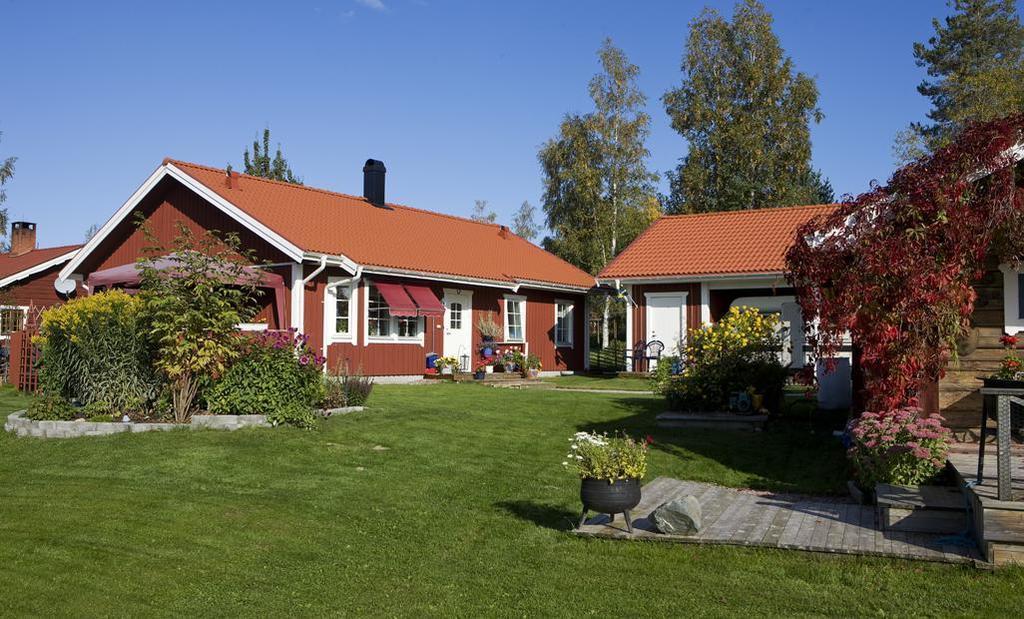Please provide a concise description of this image. These are the houses with doors and windows. This looks like a flower pot with a plant in it. I can see a chair. These are the trees. I can see small plants with flowers. This looks like a rock. Here is the grass. 